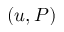Convert formula to latex. <formula><loc_0><loc_0><loc_500><loc_500>( u , P )</formula> 